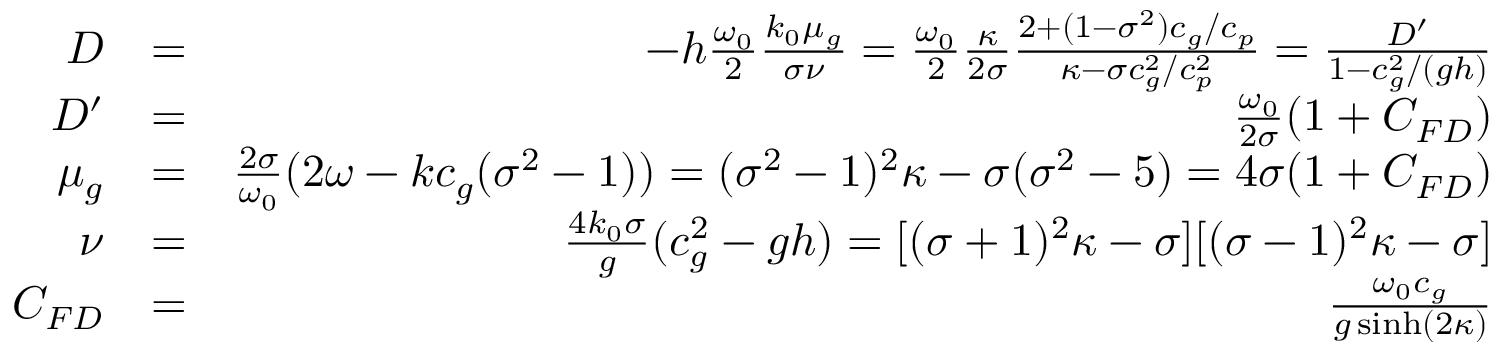<formula> <loc_0><loc_0><loc_500><loc_500>\begin{array} { r l r } { D } & { = } & { - h \frac { \omega _ { 0 } } { 2 } \frac { k _ { 0 } \mu _ { g } } { \sigma \nu } = \frac { \omega _ { 0 } } { 2 } \frac { \kappa } { 2 \sigma } \frac { 2 + ( 1 - \sigma ^ { 2 } ) c _ { g } / c _ { p } } { \kappa - \sigma c _ { g } ^ { 2 } / c _ { p } ^ { 2 } } = \frac { D ^ { \prime } } { 1 - c _ { g } ^ { 2 } / ( g h ) } } \\ { D ^ { \prime } } & { = } & { \frac { \omega _ { 0 } } { 2 \sigma } ( 1 + C _ { F D } ) } \\ { \mu _ { g } } & { = } & { \frac { 2 \sigma } { \omega _ { 0 } } ( 2 \omega - k c _ { g } ( \sigma ^ { 2 } - 1 ) ) = ( \sigma ^ { 2 } - 1 ) ^ { 2 } \kappa - \sigma ( \sigma ^ { 2 } - 5 ) = 4 \sigma ( 1 + C _ { F D } ) } \\ { \nu } & { = } & { \frac { 4 k _ { 0 } \sigma } { g } ( c _ { g } ^ { 2 } - g h ) = [ ( \sigma + 1 ) ^ { 2 } \kappa - \sigma ] [ ( \sigma - 1 ) ^ { 2 } \kappa - \sigma ] } \\ { C _ { F D } } & { = } & { \frac { \omega _ { 0 } c _ { g } } { g \sinh ( 2 \kappa ) } } \end{array}</formula> 